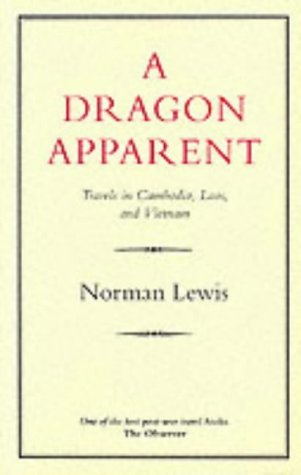Are there any specific cultural aspects explored in this book? Yes, the book highlights various cultural aspects, including detailed observations on the social practices, traditions, and the political climate in Cambodia, Laos, and Vietnam during the mid-20th century. 